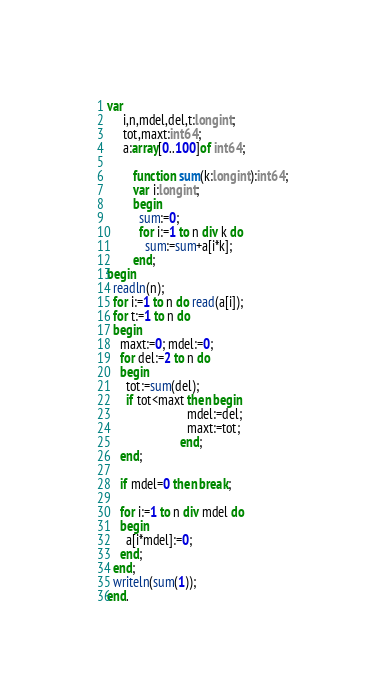<code> <loc_0><loc_0><loc_500><loc_500><_Pascal_>var
     i,n,mdel,del,t:longint;
     tot,maxt:int64;
     a:array[0..100]of int64;

        function sum(k:longint):int64;
        var i:longint;
        begin
          sum:=0;
          for i:=1 to n div k do
            sum:=sum+a[i*k];
        end;
begin
  readln(n);
  for i:=1 to n do read(a[i]);
  for t:=1 to n do
  begin
    maxt:=0; mdel:=0;
    for del:=2 to n do
    begin
      tot:=sum(del);
      if tot<maxt then begin
                         mdel:=del;
                         maxt:=tot;
                       end;
    end;

    if mdel=0 then break;

    for i:=1 to n div mdel do
    begin
      a[i*mdel]:=0;
    end;
  end;
  writeln(sum(1));
end.</code> 